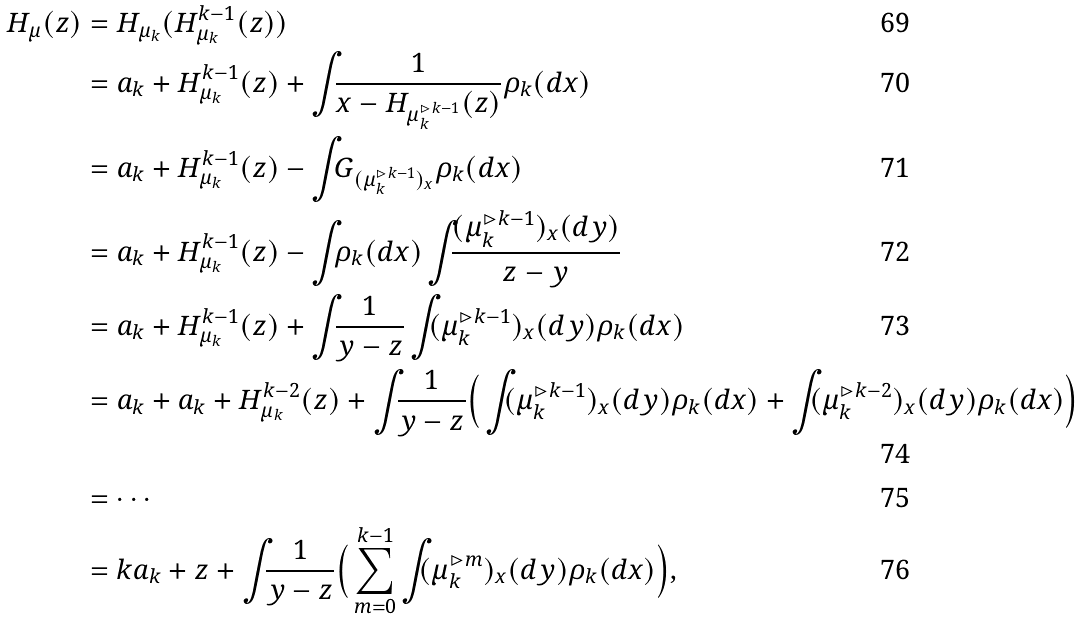Convert formula to latex. <formula><loc_0><loc_0><loc_500><loc_500>H _ { \mu } ( z ) & = H _ { \mu _ { k } } ( H ^ { k - 1 } _ { \mu _ { k } } ( z ) ) \\ & = a _ { k } + H _ { \mu _ { k } } ^ { k - 1 } ( z ) + \int _ { \real } \frac { 1 } { x - H _ { \mu _ { k } ^ { \rhd k - 1 } } ( z ) } \rho _ { k } ( d x ) \\ & = a _ { k } + H _ { \mu _ { k } } ^ { k - 1 } ( z ) - \int _ { \real } G _ { ( \mu _ { k } ^ { \rhd k - 1 } ) _ { x } } \rho _ { k } ( d x ) \\ & = a _ { k } + H _ { \mu _ { k } } ^ { k - 1 } ( z ) - \int _ { \real } \rho _ { k } ( d x ) \int _ { \real } \frac { ( \mu _ { k } ^ { \rhd k - 1 } ) _ { x } ( d y ) } { z - y } \\ & = a _ { k } + H _ { \mu _ { k } } ^ { k - 1 } ( z ) + \int _ { \real } \frac { 1 } { y - z } \int _ { \real } ( \mu _ { k } ^ { \rhd k - 1 } ) _ { x } ( d y ) \rho _ { k } ( d x ) \\ & = a _ { k } + a _ { k } + H _ { \mu _ { k } } ^ { k - 2 } ( z ) + \int _ { \real } \frac { 1 } { y - z } \Big { ( } \int _ { \real } ( \mu _ { k } ^ { \rhd k - 1 } ) _ { x } ( d y ) \rho _ { k } ( d x ) + \int _ { \real } ( \mu _ { k } ^ { \rhd k - 2 } ) _ { x } ( d y ) \rho _ { k } ( d x ) \Big { ) } \\ & = \cdots \\ & = k a _ { k } + z + \int _ { \real } \frac { 1 } { y - z } \Big { ( } \sum _ { m = 0 } ^ { k - 1 } \int _ { \real } ( \mu _ { k } ^ { \rhd m } ) _ { x } ( d y ) \rho _ { k } ( d x ) \Big { ) } ,</formula> 